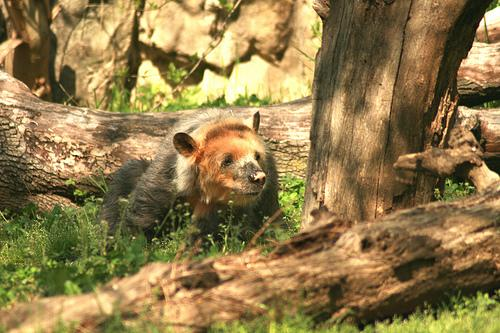If you were to advertise a product related to this image, what type of product would it be and how would you describe its connection? A wildlife photography book, capturing the beauty and natural habitat of majestic creatures like the brown bear featured in this image. What large animal is hidden in the image, and where is it hiding? A large mammal, possibly a bear, is hiding between two logs and obscured by flowers. Mention a unique feature of the animal in this image. The animal has a round head and pointed face, appearing as a furry gray, white, and brown creature. Describe the scene where the animal is positioned within the image. The animal is surrounded by three logs, some long green and yellow grass, and a cluster of ferns. In the context of visual entailment, is the statement "A bear is sleeping in a natural setting" consistent with the image? Yes, the statement is consistent as there's a sleeping brown bear lying on the ground in a natural setting. For the multi-choice VQA task, which of the following best describes the main focus of the image? (A) fallen tree trunks, (B) grass and flowers, (C) a large bear (C) a large bear Refer to the tree behind the log; what words best describe it? Thick tree with a standing brown tree trunk. Identify the animal and its state in the image. A sleeping brown bear lying on the ground surrounded by leaves and grass. Describe the background of the image concerning its different elements. The image has a molded rock style concrete wall, long dead decomposing log, grass in the foreground, and a standing brown tree trunk in the background. 